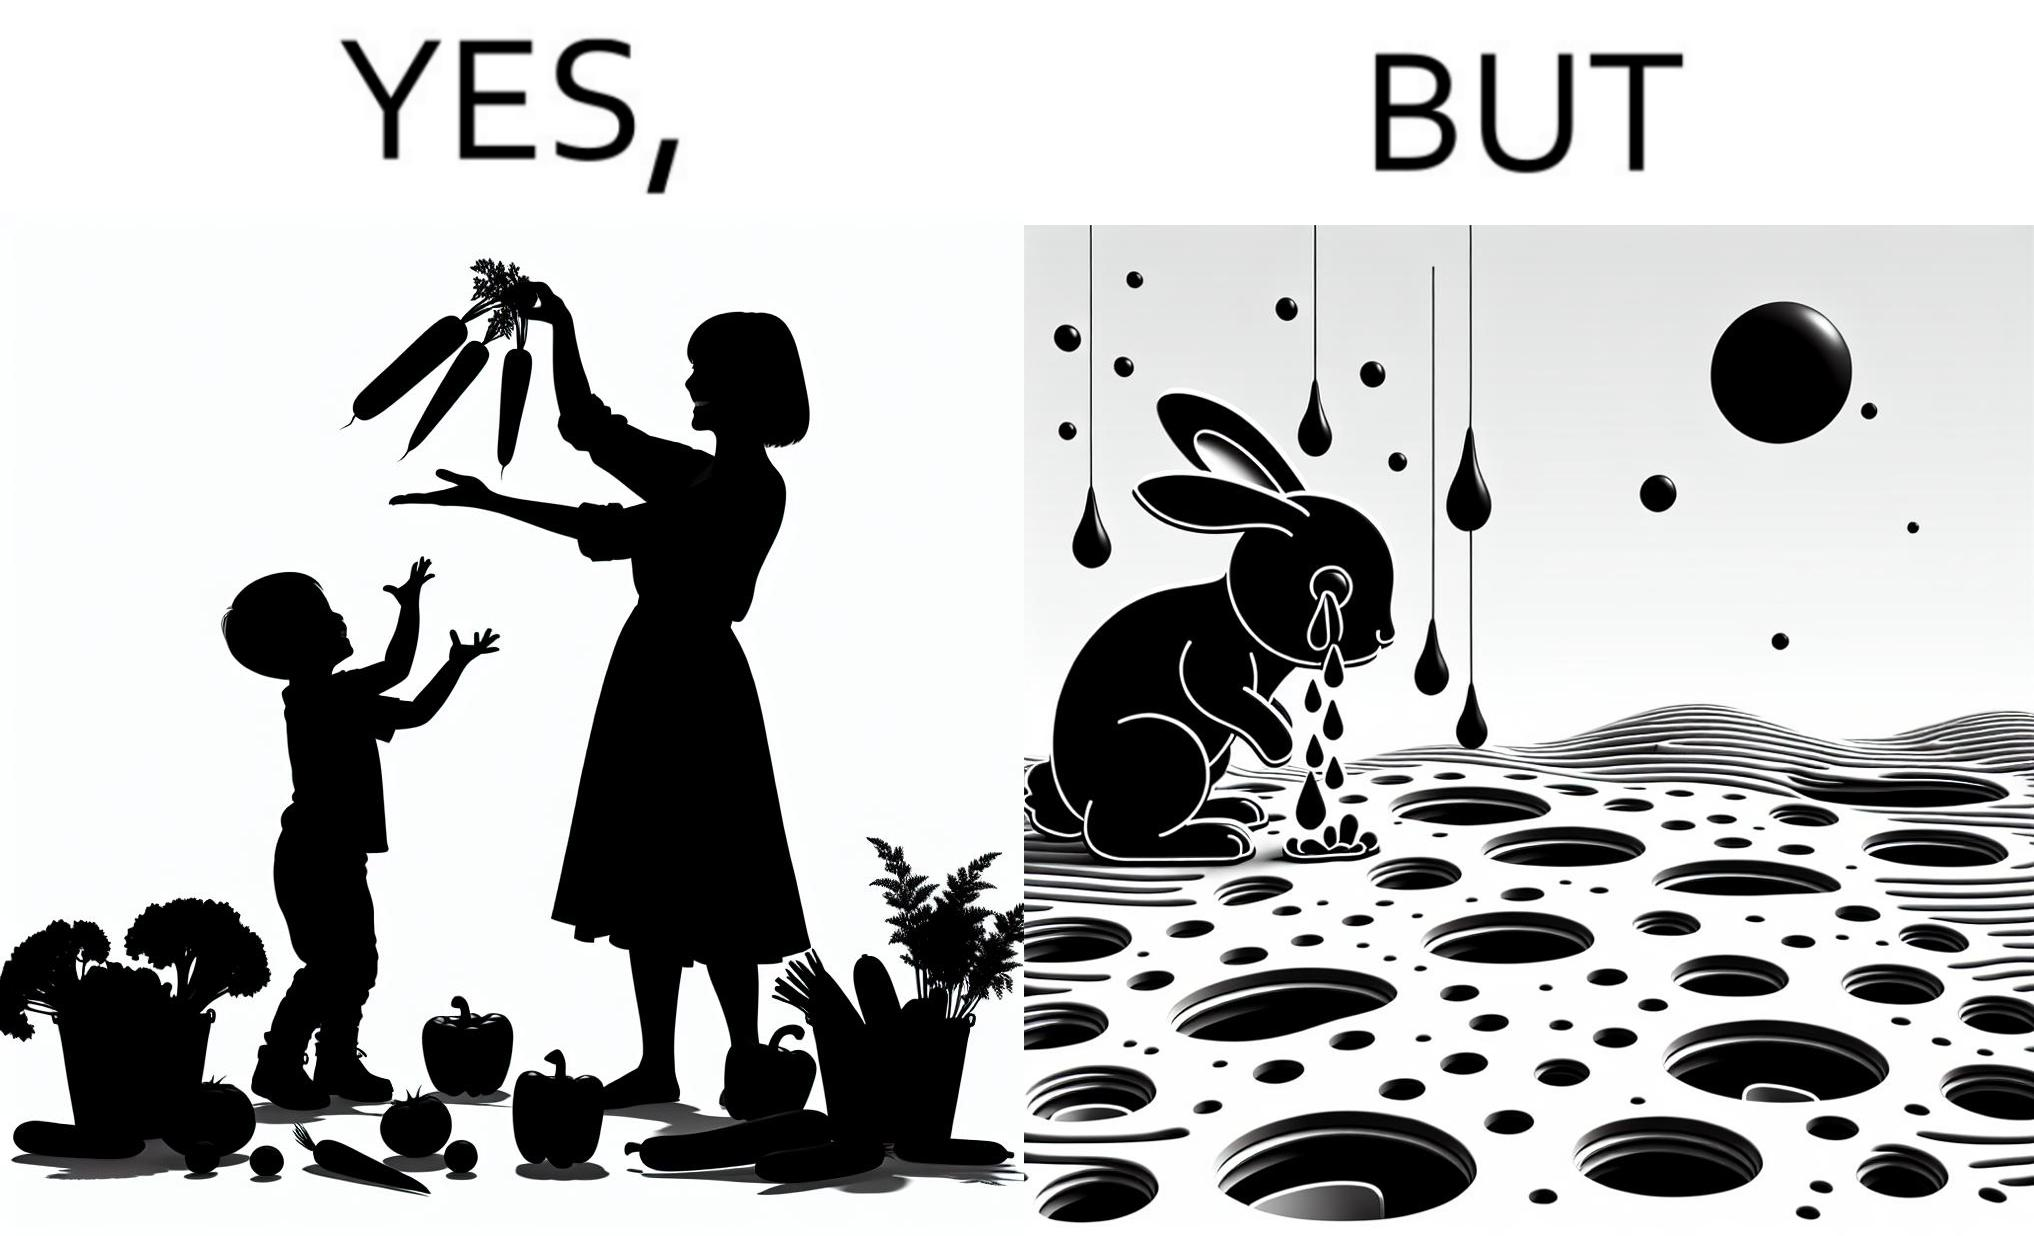Describe the content of this image. The images are ironic since they show how on one hand humans choose to play with and waste foods like vegetables while the animals are unable to eat enough food and end up starving due to lack of food 